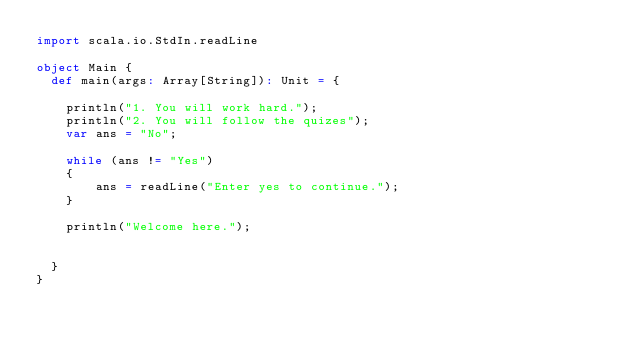<code> <loc_0><loc_0><loc_500><loc_500><_Scala_>import scala.io.StdIn.readLine

object Main {
  def main(args: Array[String]): Unit = {

    println("1. You will work hard.");
    println("2. You will follow the quizes");
    var ans = "No";

    while (ans != "Yes")
    {
        ans = readLine("Enter yes to continue.");
    }

    println("Welcome here.");
    

  }
}
</code> 